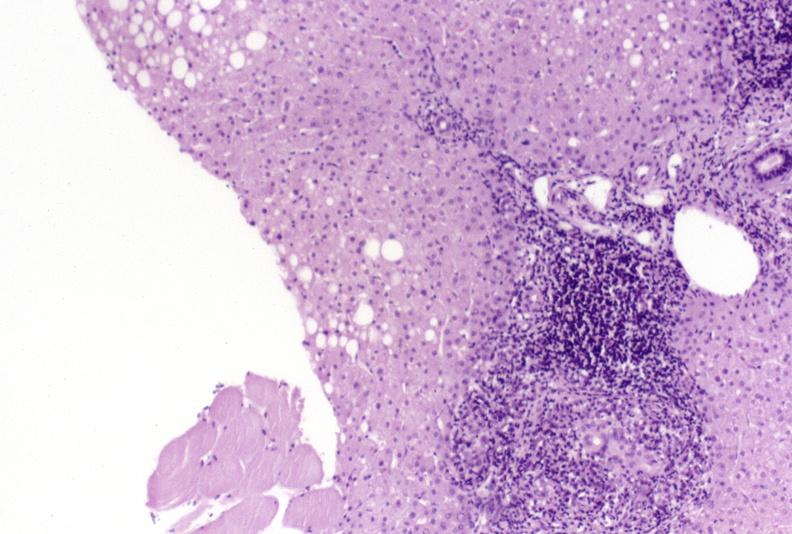what is present?
Answer the question using a single word or phrase. Hepatobiliary 